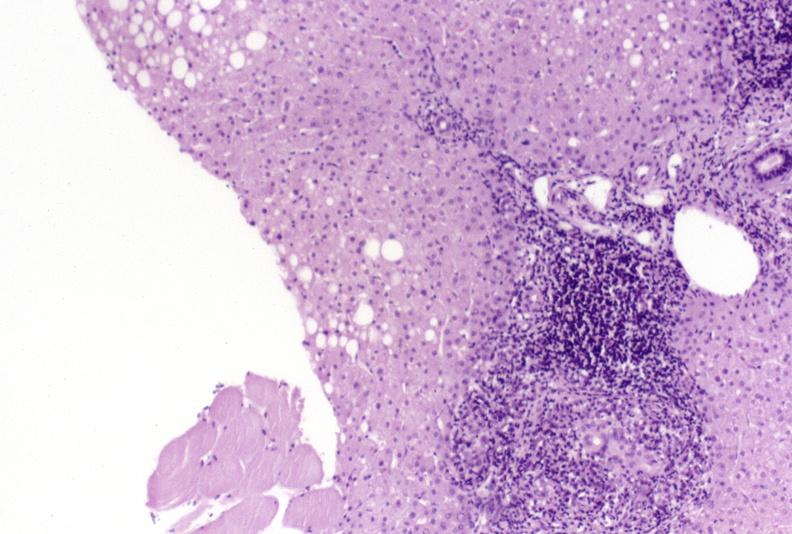what is present?
Answer the question using a single word or phrase. Hepatobiliary 